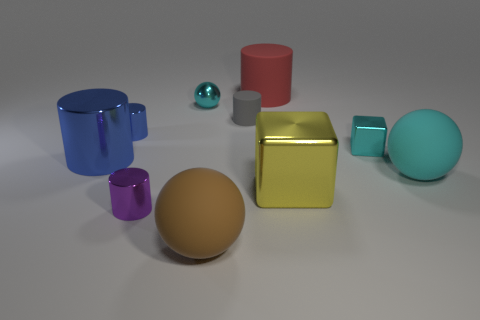Is there anything else that is the same material as the brown sphere?
Ensure brevity in your answer.  Yes. Are the large blue cylinder and the small object that is in front of the small shiny cube made of the same material?
Your answer should be compact. Yes. What shape is the big object on the left side of the blue cylinder that is behind the large blue thing?
Provide a short and direct response. Cylinder. What number of large objects are either red blocks or yellow objects?
Your answer should be compact. 1. What number of cyan shiny things are the same shape as the brown rubber object?
Provide a short and direct response. 1. There is a purple object; is its shape the same as the big cyan thing that is to the right of the large red object?
Keep it short and to the point. No. What number of cyan matte balls are on the right side of the tiny rubber thing?
Your answer should be very brief. 1. Are there any gray cylinders that have the same size as the red rubber cylinder?
Provide a succinct answer. No. Is the shape of the large red thing to the left of the large cyan thing the same as  the big yellow shiny object?
Offer a very short reply. No. What is the color of the large block?
Your response must be concise. Yellow. 